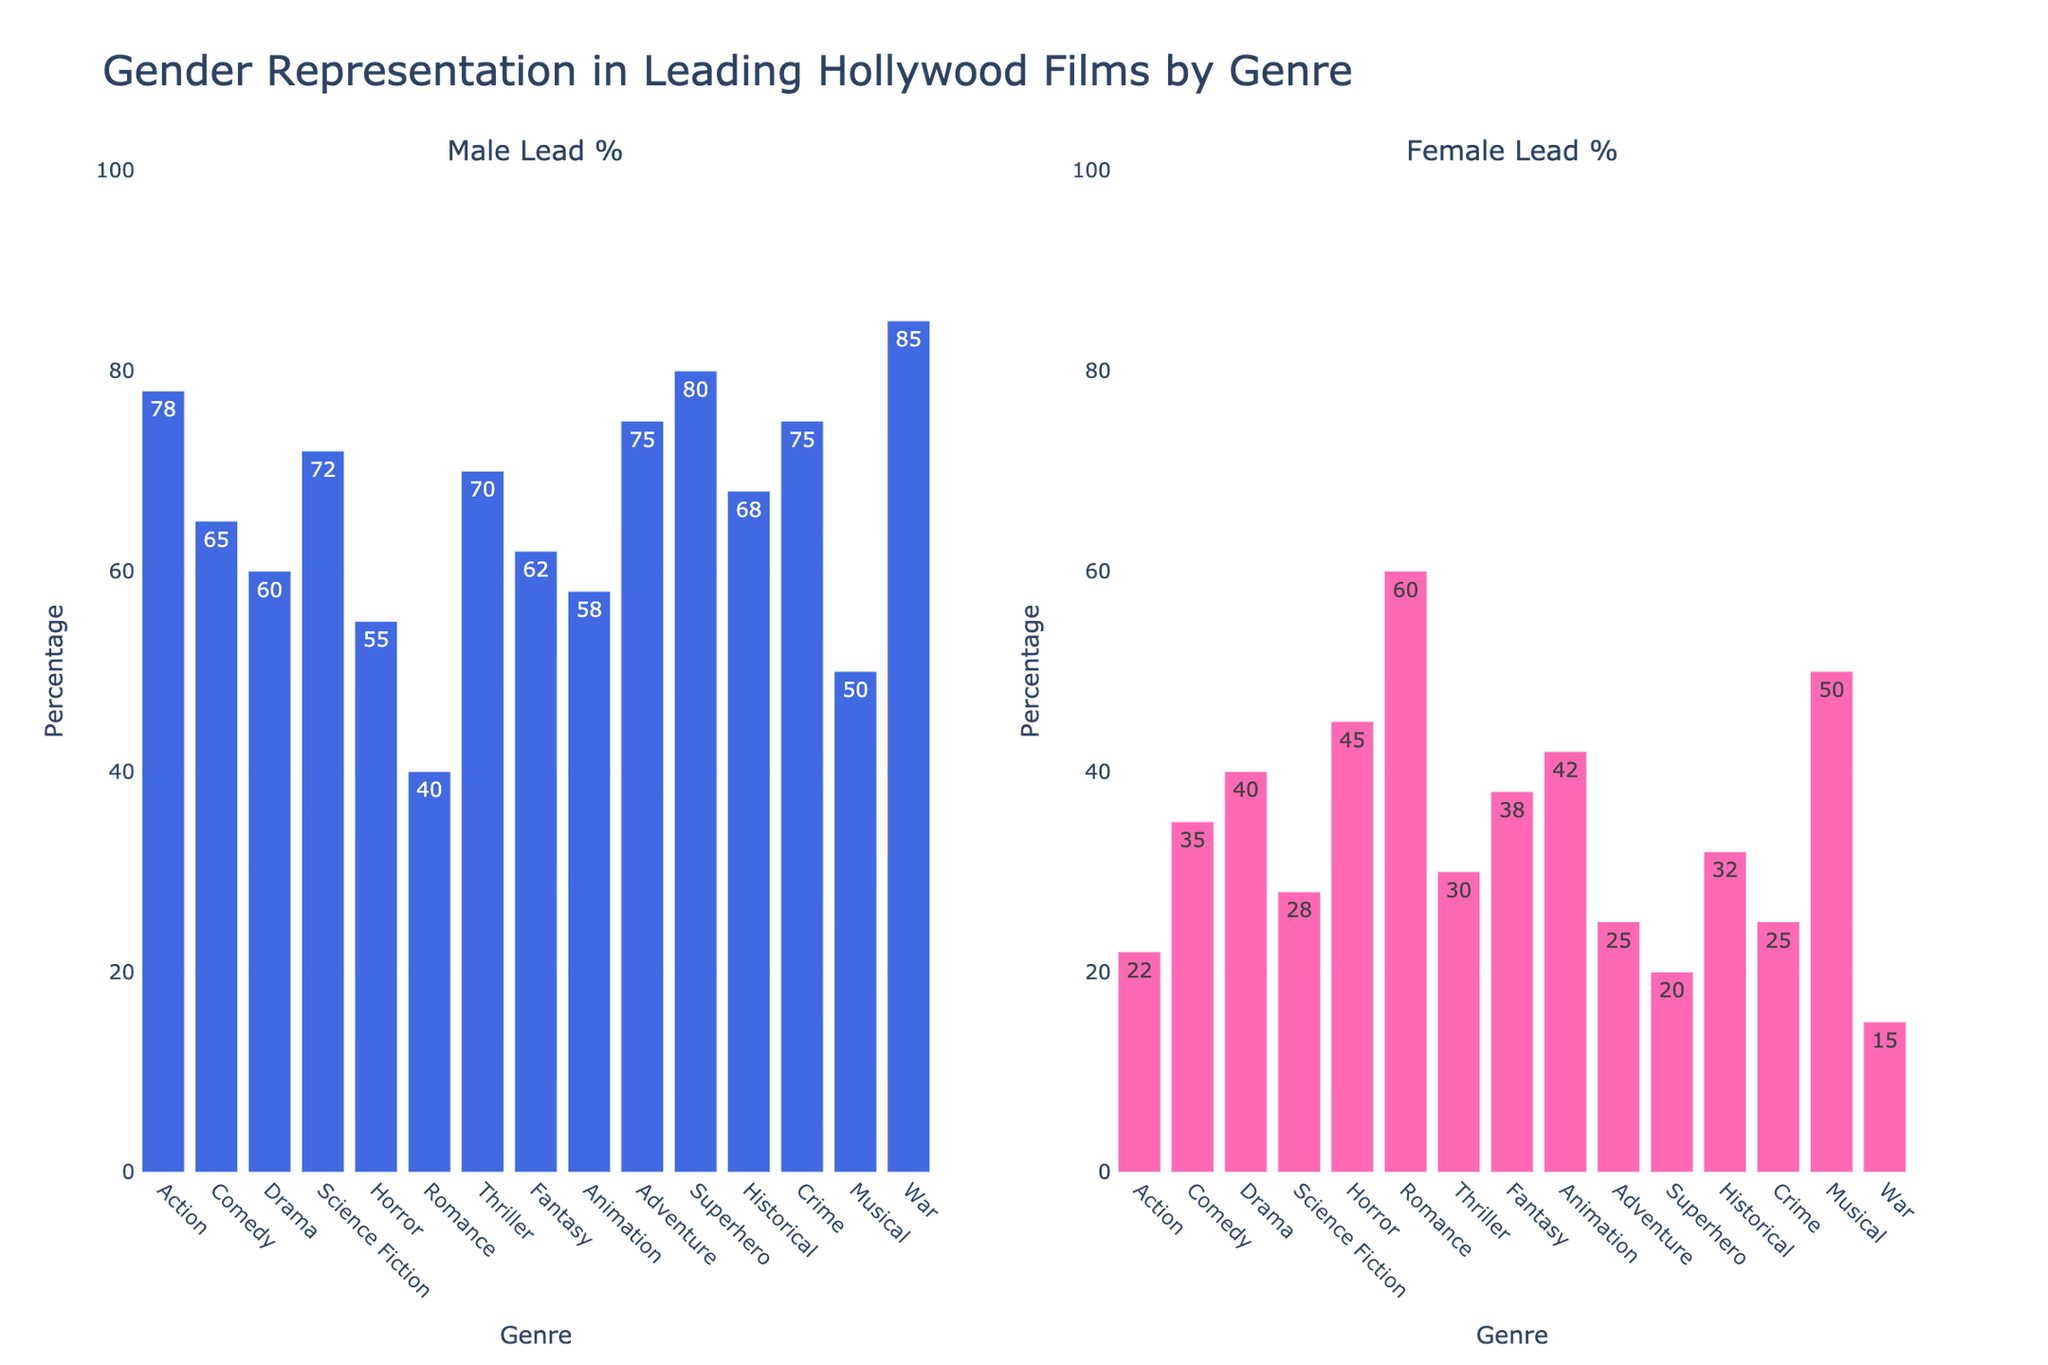Which genre has the highest percentage of male leads? The bar representing the male leads in the "War" genre is the tallest, indicating the highest percentage.
Answer: War Which genre has a higher percentage of female leads: Science Fiction or Fantasy? The "Fantasy" genre bar is taller for female leads (38%) compared to the "Science Fiction" genre (28%).
Answer: Fantasy What's the percentage difference in female leads between Romance and Action genres? Female leads in "Romance" is 60% and in "Action" 22%. The difference is 60% - 22% = 38%.
Answer: 38% Which genre has an equal percentage of male and female leads? Only the bar corresponding to "Musical" shows 50% for both male and female leads.
Answer: Musical Are there more genres with a higher percentage of male leads than female leads? Count the genres with male leads higher than female leads. There are more such genres (Action, Comedy, Drama, Science Fiction, Horror, Thriller, Fantasy, Animation, Adventure, Superhero, Historical, Crime, War) than those with higher female leads (Romance, Musical).
Answer: Yes What is the combined percentage of female leads in Comedy and Drama? Female leads in "Comedy" is 35% and in "Drama" is 40%. The combined percentage is 35% + 40% = 75%.
Answer: 75% Which genre has a lower percentage of female leads: Thriller or Historical? "Thriller" has 30% female leads and "Historical" has 32%. Thus, "Thriller" has a lower percentage.
Answer: Thriller What is the average percentage of male leads across all genres? Sum the percentages of male leads across all genres and divide by the number of genres. (78 + 65 + 60 + 72 + 55 + 40 + 70 + 62 + 58 + 75 + 80 + 68 + 75 + 50 + 85) / 15 = 66.13%.
Answer: 66.13% Which genre shows the most balanced gender representation? The "Musical" genre has an equal percentage (50%) for both male and female leads, showing the most balanced representation.
Answer: Musical Is the percentage of female leads in Animation greater than in Action? Female leads in "Animation" is 42%, while in "Action" it's 22%. Since 42% is greater than 22%, the percentage is indeed greater.
Answer: Yes 